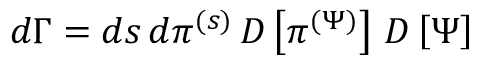Convert formula to latex. <formula><loc_0><loc_0><loc_500><loc_500>\begin{array} { r } { d \Gamma = d s \, d \pi ^ { ( s ) } \, D \left [ \pi ^ { ( \Psi ) } \right ] \, D \left [ \Psi \right ] } \end{array}</formula> 